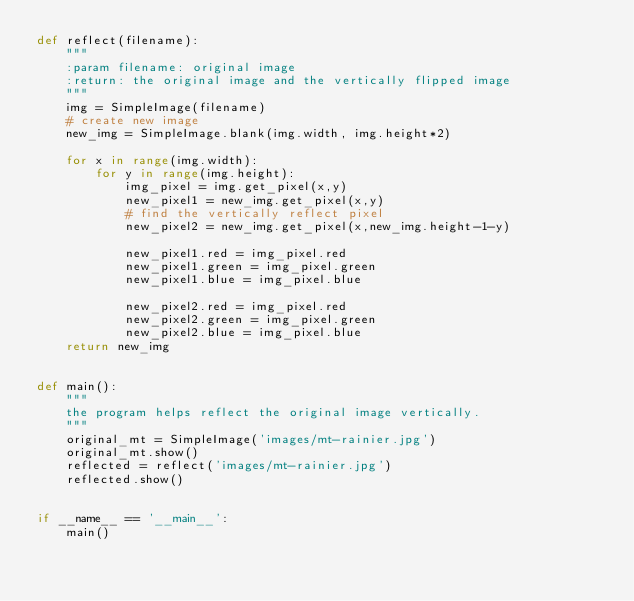Convert code to text. <code><loc_0><loc_0><loc_500><loc_500><_Python_>def reflect(filename):
    """
    :param filename: original image
    :return: the original image and the vertically flipped image
    """
    img = SimpleImage(filename)
    # create new image
    new_img = SimpleImage.blank(img.width, img.height*2)

    for x in range(img.width):
        for y in range(img.height):
            img_pixel = img.get_pixel(x,y)
            new_pixel1 = new_img.get_pixel(x,y)
            # find the vertically reflect pixel
            new_pixel2 = new_img.get_pixel(x,new_img.height-1-y)

            new_pixel1.red = img_pixel.red
            new_pixel1.green = img_pixel.green
            new_pixel1.blue = img_pixel.blue

            new_pixel2.red = img_pixel.red
            new_pixel2.green = img_pixel.green
            new_pixel2.blue = img_pixel.blue
    return new_img


def main():
    """
    the program helps reflect the original image vertically.
    """
    original_mt = SimpleImage('images/mt-rainier.jpg')
    original_mt.show()
    reflected = reflect('images/mt-rainier.jpg')
    reflected.show()


if __name__ == '__main__':
    main()
</code> 